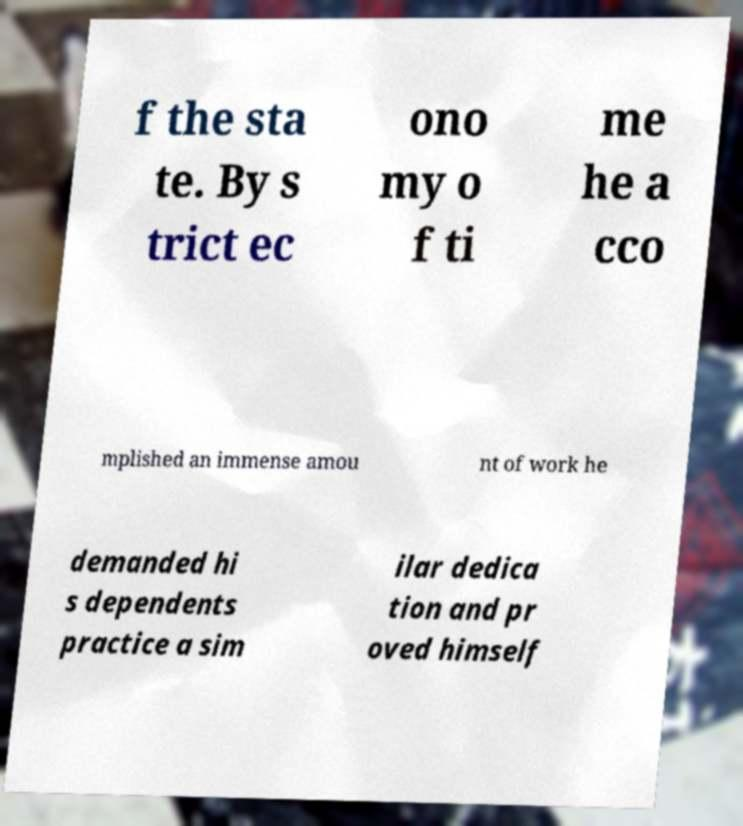Can you read and provide the text displayed in the image?This photo seems to have some interesting text. Can you extract and type it out for me? f the sta te. By s trict ec ono my o f ti me he a cco mplished an immense amou nt of work he demanded hi s dependents practice a sim ilar dedica tion and pr oved himself 